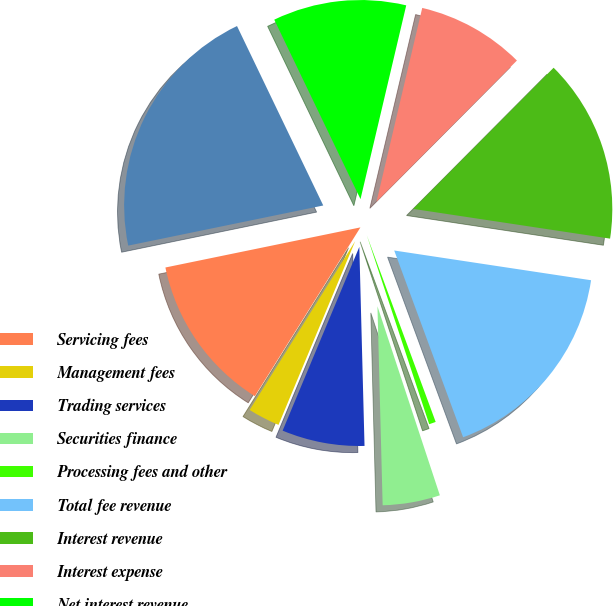<chart> <loc_0><loc_0><loc_500><loc_500><pie_chart><fcel>Servicing fees<fcel>Management fees<fcel>Trading services<fcel>Securities finance<fcel>Processing fees and other<fcel>Total fee revenue<fcel>Interest revenue<fcel>Interest expense<fcel>Net interest revenue<fcel>Total revenue<nl><fcel>12.88%<fcel>2.6%<fcel>6.71%<fcel>4.66%<fcel>0.55%<fcel>16.99%<fcel>14.93%<fcel>8.77%<fcel>10.82%<fcel>21.1%<nl></chart> 